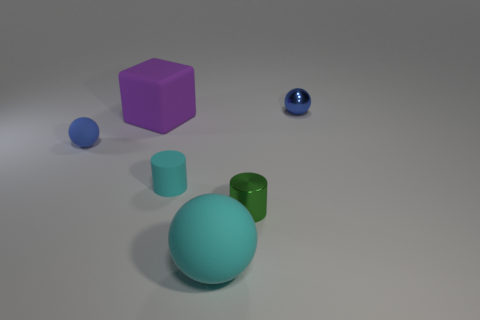Add 2 big cyan matte balls. How many objects exist? 8 Subtract all cylinders. How many objects are left? 4 Add 6 small things. How many small things exist? 10 Subtract 0 yellow blocks. How many objects are left? 6 Subtract all small cyan objects. Subtract all blue metal balls. How many objects are left? 4 Add 3 tiny blue matte things. How many tiny blue matte things are left? 4 